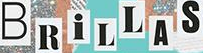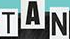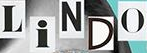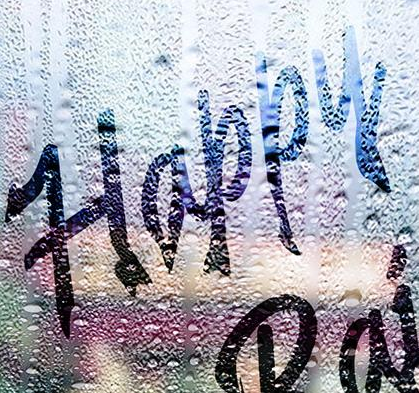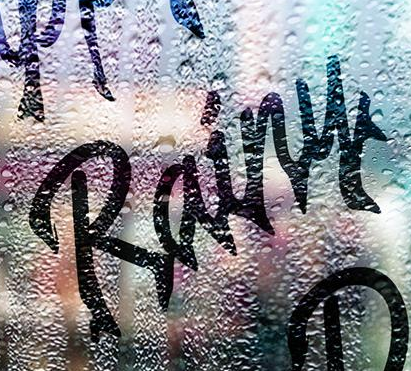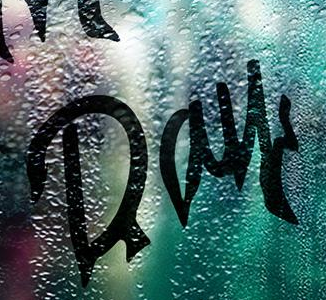Transcribe the words shown in these images in order, separated by a semicolon. BRiLLAS; TAN; LiNDO; Happy; Rainy; Day 